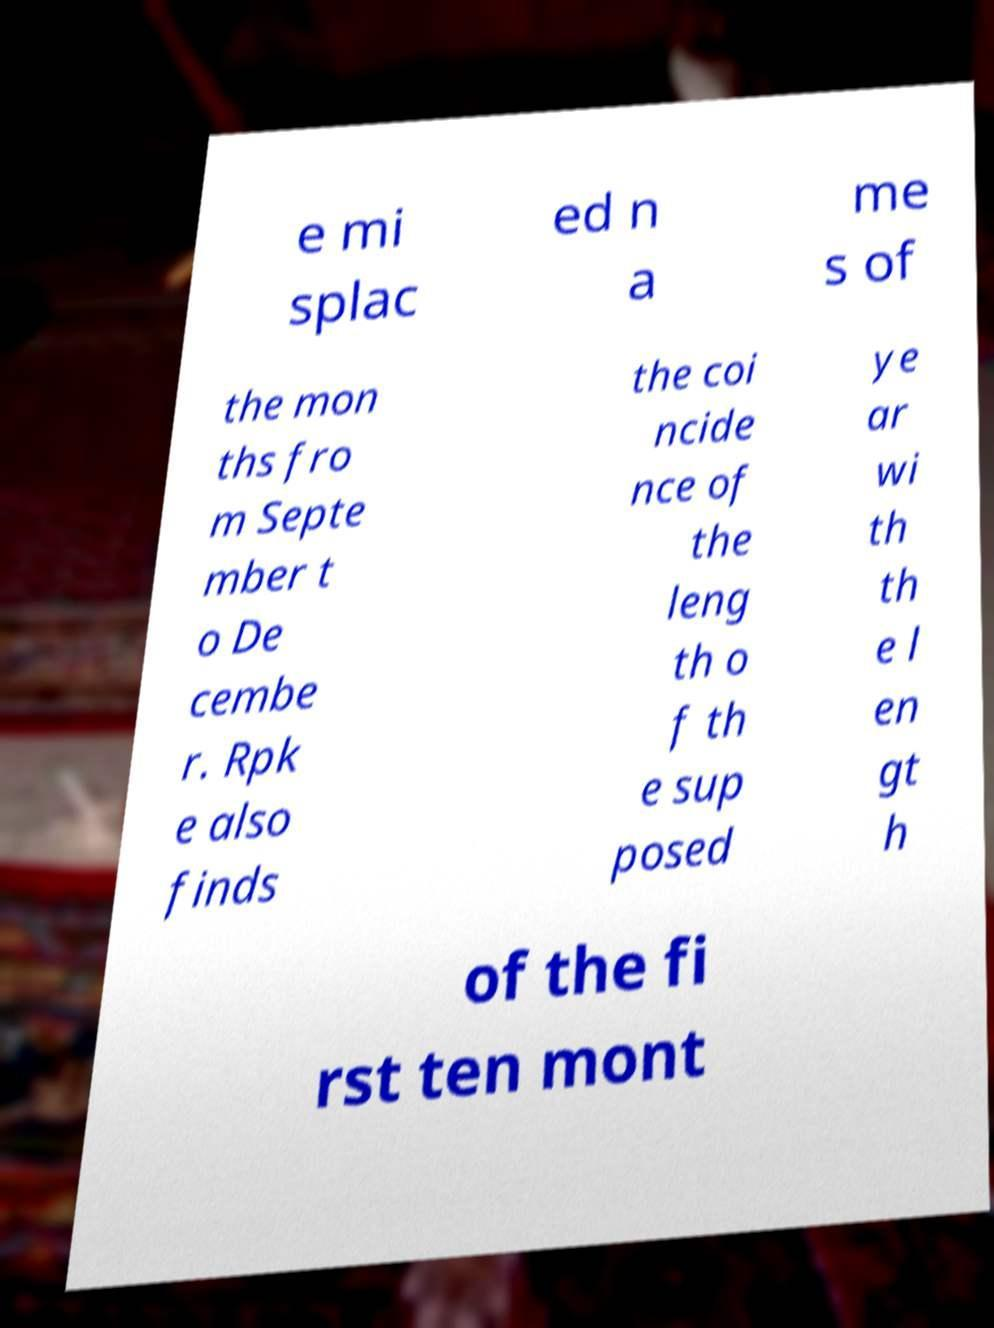Can you read and provide the text displayed in the image?This photo seems to have some interesting text. Can you extract and type it out for me? e mi splac ed n a me s of the mon ths fro m Septe mber t o De cembe r. Rpk e also finds the coi ncide nce of the leng th o f th e sup posed ye ar wi th th e l en gt h of the fi rst ten mont 